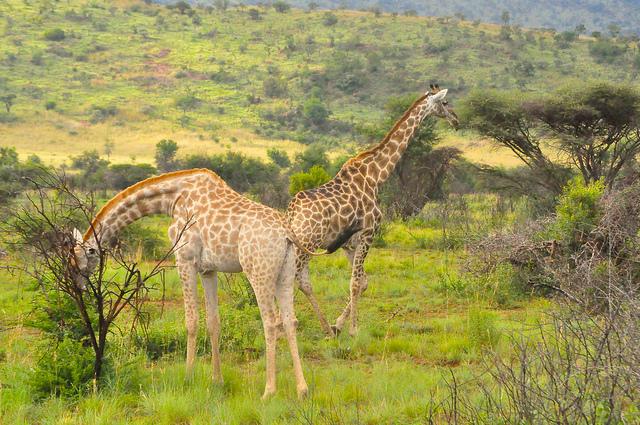Do all the trees have leaves?
Quick response, please. No. Is there a hill?
Concise answer only. Yes. Are these giraffes in a zoo?
Answer briefly. No. 